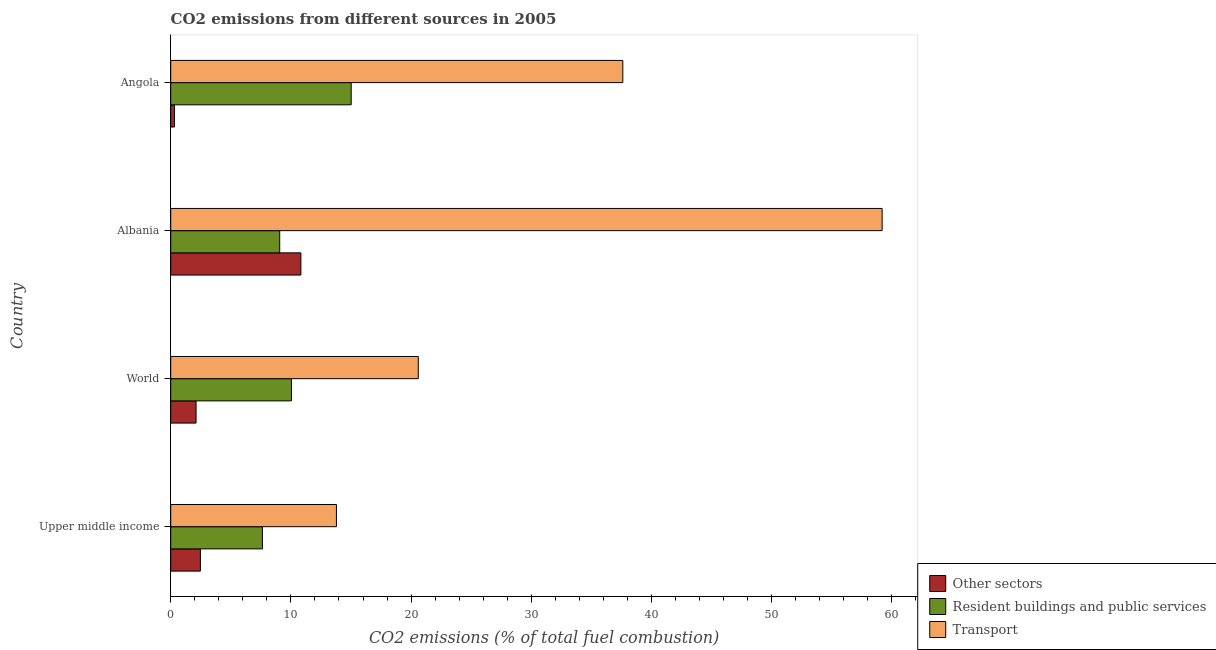Are the number of bars per tick equal to the number of legend labels?
Keep it short and to the point. Yes. How many bars are there on the 3rd tick from the bottom?
Ensure brevity in your answer.  3. What is the percentage of co2 emissions from transport in Upper middle income?
Make the answer very short. 13.79. Across all countries, what is the maximum percentage of co2 emissions from other sectors?
Your answer should be very brief. 10.83. Across all countries, what is the minimum percentage of co2 emissions from resident buildings and public services?
Provide a succinct answer. 7.63. In which country was the percentage of co2 emissions from resident buildings and public services maximum?
Ensure brevity in your answer.  Angola. In which country was the percentage of co2 emissions from transport minimum?
Provide a short and direct response. Upper middle income. What is the total percentage of co2 emissions from transport in the graph?
Your answer should be very brief. 131.2. What is the difference between the percentage of co2 emissions from other sectors in Albania and that in Angola?
Give a very brief answer. 10.52. What is the difference between the percentage of co2 emissions from resident buildings and public services in Angola and the percentage of co2 emissions from other sectors in Albania?
Provide a short and direct response. 4.18. What is the average percentage of co2 emissions from transport per country?
Your answer should be compact. 32.8. What is the difference between the percentage of co2 emissions from transport and percentage of co2 emissions from resident buildings and public services in Albania?
Your answer should be compact. 50.13. In how many countries, is the percentage of co2 emissions from other sectors greater than 60 %?
Your response must be concise. 0. What is the ratio of the percentage of co2 emissions from other sectors in Upper middle income to that in World?
Provide a short and direct response. 1.17. Is the percentage of co2 emissions from resident buildings and public services in Angola less than that in World?
Keep it short and to the point. No. What is the difference between the highest and the second highest percentage of co2 emissions from transport?
Ensure brevity in your answer.  21.58. What is the difference between the highest and the lowest percentage of co2 emissions from transport?
Offer a terse response. 45.41. In how many countries, is the percentage of co2 emissions from other sectors greater than the average percentage of co2 emissions from other sectors taken over all countries?
Your answer should be compact. 1. What does the 1st bar from the top in World represents?
Give a very brief answer. Transport. What does the 1st bar from the bottom in World represents?
Your answer should be compact. Other sectors. Is it the case that in every country, the sum of the percentage of co2 emissions from other sectors and percentage of co2 emissions from resident buildings and public services is greater than the percentage of co2 emissions from transport?
Provide a short and direct response. No. Are all the bars in the graph horizontal?
Provide a short and direct response. Yes. What is the difference between two consecutive major ticks on the X-axis?
Provide a succinct answer. 10. How many legend labels are there?
Ensure brevity in your answer.  3. What is the title of the graph?
Offer a very short reply. CO2 emissions from different sources in 2005. Does "Transport services" appear as one of the legend labels in the graph?
Give a very brief answer. No. What is the label or title of the X-axis?
Provide a succinct answer. CO2 emissions (% of total fuel combustion). What is the label or title of the Y-axis?
Your answer should be compact. Country. What is the CO2 emissions (% of total fuel combustion) of Other sectors in Upper middle income?
Offer a very short reply. 2.47. What is the CO2 emissions (% of total fuel combustion) in Resident buildings and public services in Upper middle income?
Ensure brevity in your answer.  7.63. What is the CO2 emissions (% of total fuel combustion) in Transport in Upper middle income?
Keep it short and to the point. 13.79. What is the CO2 emissions (% of total fuel combustion) of Other sectors in World?
Ensure brevity in your answer.  2.11. What is the CO2 emissions (% of total fuel combustion) in Resident buildings and public services in World?
Provide a short and direct response. 10.05. What is the CO2 emissions (% of total fuel combustion) in Transport in World?
Your answer should be compact. 20.6. What is the CO2 emissions (% of total fuel combustion) of Other sectors in Albania?
Provide a short and direct response. 10.83. What is the CO2 emissions (% of total fuel combustion) of Resident buildings and public services in Albania?
Provide a short and direct response. 9.07. What is the CO2 emissions (% of total fuel combustion) in Transport in Albania?
Offer a very short reply. 59.19. What is the CO2 emissions (% of total fuel combustion) in Other sectors in Angola?
Keep it short and to the point. 0.31. What is the CO2 emissions (% of total fuel combustion) of Resident buildings and public services in Angola?
Make the answer very short. 15.02. What is the CO2 emissions (% of total fuel combustion) in Transport in Angola?
Offer a very short reply. 37.62. Across all countries, what is the maximum CO2 emissions (% of total fuel combustion) of Other sectors?
Your answer should be compact. 10.83. Across all countries, what is the maximum CO2 emissions (% of total fuel combustion) of Resident buildings and public services?
Your answer should be compact. 15.02. Across all countries, what is the maximum CO2 emissions (% of total fuel combustion) of Transport?
Ensure brevity in your answer.  59.19. Across all countries, what is the minimum CO2 emissions (% of total fuel combustion) of Other sectors?
Your answer should be very brief. 0.31. Across all countries, what is the minimum CO2 emissions (% of total fuel combustion) in Resident buildings and public services?
Make the answer very short. 7.63. Across all countries, what is the minimum CO2 emissions (% of total fuel combustion) of Transport?
Provide a succinct answer. 13.79. What is the total CO2 emissions (% of total fuel combustion) of Other sectors in the graph?
Offer a very short reply. 15.72. What is the total CO2 emissions (% of total fuel combustion) of Resident buildings and public services in the graph?
Your answer should be very brief. 41.76. What is the total CO2 emissions (% of total fuel combustion) of Transport in the graph?
Give a very brief answer. 131.2. What is the difference between the CO2 emissions (% of total fuel combustion) of Other sectors in Upper middle income and that in World?
Ensure brevity in your answer.  0.36. What is the difference between the CO2 emissions (% of total fuel combustion) of Resident buildings and public services in Upper middle income and that in World?
Offer a terse response. -2.42. What is the difference between the CO2 emissions (% of total fuel combustion) in Transport in Upper middle income and that in World?
Your answer should be compact. -6.81. What is the difference between the CO2 emissions (% of total fuel combustion) of Other sectors in Upper middle income and that in Albania?
Make the answer very short. -8.36. What is the difference between the CO2 emissions (% of total fuel combustion) of Resident buildings and public services in Upper middle income and that in Albania?
Provide a short and direct response. -1.44. What is the difference between the CO2 emissions (% of total fuel combustion) in Transport in Upper middle income and that in Albania?
Provide a succinct answer. -45.41. What is the difference between the CO2 emissions (% of total fuel combustion) in Other sectors in Upper middle income and that in Angola?
Your response must be concise. 2.16. What is the difference between the CO2 emissions (% of total fuel combustion) in Resident buildings and public services in Upper middle income and that in Angola?
Keep it short and to the point. -7.39. What is the difference between the CO2 emissions (% of total fuel combustion) in Transport in Upper middle income and that in Angola?
Offer a very short reply. -23.83. What is the difference between the CO2 emissions (% of total fuel combustion) in Other sectors in World and that in Albania?
Keep it short and to the point. -8.72. What is the difference between the CO2 emissions (% of total fuel combustion) of Resident buildings and public services in World and that in Albania?
Your answer should be compact. 0.98. What is the difference between the CO2 emissions (% of total fuel combustion) in Transport in World and that in Albania?
Offer a terse response. -38.6. What is the difference between the CO2 emissions (% of total fuel combustion) in Other sectors in World and that in Angola?
Offer a terse response. 1.8. What is the difference between the CO2 emissions (% of total fuel combustion) of Resident buildings and public services in World and that in Angola?
Your answer should be compact. -4.97. What is the difference between the CO2 emissions (% of total fuel combustion) in Transport in World and that in Angola?
Keep it short and to the point. -17.02. What is the difference between the CO2 emissions (% of total fuel combustion) of Other sectors in Albania and that in Angola?
Your response must be concise. 10.52. What is the difference between the CO2 emissions (% of total fuel combustion) in Resident buildings and public services in Albania and that in Angola?
Offer a very short reply. -5.95. What is the difference between the CO2 emissions (% of total fuel combustion) of Transport in Albania and that in Angola?
Provide a short and direct response. 21.58. What is the difference between the CO2 emissions (% of total fuel combustion) in Other sectors in Upper middle income and the CO2 emissions (% of total fuel combustion) in Resident buildings and public services in World?
Your answer should be compact. -7.58. What is the difference between the CO2 emissions (% of total fuel combustion) in Other sectors in Upper middle income and the CO2 emissions (% of total fuel combustion) in Transport in World?
Keep it short and to the point. -18.13. What is the difference between the CO2 emissions (% of total fuel combustion) in Resident buildings and public services in Upper middle income and the CO2 emissions (% of total fuel combustion) in Transport in World?
Your answer should be very brief. -12.97. What is the difference between the CO2 emissions (% of total fuel combustion) in Other sectors in Upper middle income and the CO2 emissions (% of total fuel combustion) in Resident buildings and public services in Albania?
Your response must be concise. -6.6. What is the difference between the CO2 emissions (% of total fuel combustion) of Other sectors in Upper middle income and the CO2 emissions (% of total fuel combustion) of Transport in Albania?
Ensure brevity in your answer.  -56.72. What is the difference between the CO2 emissions (% of total fuel combustion) in Resident buildings and public services in Upper middle income and the CO2 emissions (% of total fuel combustion) in Transport in Albania?
Give a very brief answer. -51.56. What is the difference between the CO2 emissions (% of total fuel combustion) in Other sectors in Upper middle income and the CO2 emissions (% of total fuel combustion) in Resident buildings and public services in Angola?
Your response must be concise. -12.55. What is the difference between the CO2 emissions (% of total fuel combustion) in Other sectors in Upper middle income and the CO2 emissions (% of total fuel combustion) in Transport in Angola?
Give a very brief answer. -35.15. What is the difference between the CO2 emissions (% of total fuel combustion) of Resident buildings and public services in Upper middle income and the CO2 emissions (% of total fuel combustion) of Transport in Angola?
Ensure brevity in your answer.  -29.99. What is the difference between the CO2 emissions (% of total fuel combustion) in Other sectors in World and the CO2 emissions (% of total fuel combustion) in Resident buildings and public services in Albania?
Your answer should be very brief. -6.96. What is the difference between the CO2 emissions (% of total fuel combustion) in Other sectors in World and the CO2 emissions (% of total fuel combustion) in Transport in Albania?
Provide a succinct answer. -57.09. What is the difference between the CO2 emissions (% of total fuel combustion) of Resident buildings and public services in World and the CO2 emissions (% of total fuel combustion) of Transport in Albania?
Offer a very short reply. -49.15. What is the difference between the CO2 emissions (% of total fuel combustion) of Other sectors in World and the CO2 emissions (% of total fuel combustion) of Resident buildings and public services in Angola?
Provide a succinct answer. -12.91. What is the difference between the CO2 emissions (% of total fuel combustion) in Other sectors in World and the CO2 emissions (% of total fuel combustion) in Transport in Angola?
Your answer should be very brief. -35.51. What is the difference between the CO2 emissions (% of total fuel combustion) in Resident buildings and public services in World and the CO2 emissions (% of total fuel combustion) in Transport in Angola?
Offer a terse response. -27.57. What is the difference between the CO2 emissions (% of total fuel combustion) of Other sectors in Albania and the CO2 emissions (% of total fuel combustion) of Resident buildings and public services in Angola?
Offer a terse response. -4.18. What is the difference between the CO2 emissions (% of total fuel combustion) of Other sectors in Albania and the CO2 emissions (% of total fuel combustion) of Transport in Angola?
Offer a very short reply. -26.78. What is the difference between the CO2 emissions (% of total fuel combustion) in Resident buildings and public services in Albania and the CO2 emissions (% of total fuel combustion) in Transport in Angola?
Provide a short and direct response. -28.55. What is the average CO2 emissions (% of total fuel combustion) of Other sectors per country?
Provide a succinct answer. 3.93. What is the average CO2 emissions (% of total fuel combustion) of Resident buildings and public services per country?
Provide a succinct answer. 10.44. What is the average CO2 emissions (% of total fuel combustion) of Transport per country?
Give a very brief answer. 32.8. What is the difference between the CO2 emissions (% of total fuel combustion) in Other sectors and CO2 emissions (% of total fuel combustion) in Resident buildings and public services in Upper middle income?
Ensure brevity in your answer.  -5.16. What is the difference between the CO2 emissions (% of total fuel combustion) of Other sectors and CO2 emissions (% of total fuel combustion) of Transport in Upper middle income?
Keep it short and to the point. -11.32. What is the difference between the CO2 emissions (% of total fuel combustion) in Resident buildings and public services and CO2 emissions (% of total fuel combustion) in Transport in Upper middle income?
Give a very brief answer. -6.16. What is the difference between the CO2 emissions (% of total fuel combustion) of Other sectors and CO2 emissions (% of total fuel combustion) of Resident buildings and public services in World?
Your answer should be compact. -7.94. What is the difference between the CO2 emissions (% of total fuel combustion) in Other sectors and CO2 emissions (% of total fuel combustion) in Transport in World?
Give a very brief answer. -18.49. What is the difference between the CO2 emissions (% of total fuel combustion) in Resident buildings and public services and CO2 emissions (% of total fuel combustion) in Transport in World?
Offer a terse response. -10.55. What is the difference between the CO2 emissions (% of total fuel combustion) in Other sectors and CO2 emissions (% of total fuel combustion) in Resident buildings and public services in Albania?
Your answer should be very brief. 1.76. What is the difference between the CO2 emissions (% of total fuel combustion) of Other sectors and CO2 emissions (% of total fuel combustion) of Transport in Albania?
Give a very brief answer. -48.36. What is the difference between the CO2 emissions (% of total fuel combustion) in Resident buildings and public services and CO2 emissions (% of total fuel combustion) in Transport in Albania?
Make the answer very short. -50.13. What is the difference between the CO2 emissions (% of total fuel combustion) in Other sectors and CO2 emissions (% of total fuel combustion) in Resident buildings and public services in Angola?
Provide a succinct answer. -14.71. What is the difference between the CO2 emissions (% of total fuel combustion) in Other sectors and CO2 emissions (% of total fuel combustion) in Transport in Angola?
Offer a terse response. -37.31. What is the difference between the CO2 emissions (% of total fuel combustion) in Resident buildings and public services and CO2 emissions (% of total fuel combustion) in Transport in Angola?
Your answer should be compact. -22.6. What is the ratio of the CO2 emissions (% of total fuel combustion) in Other sectors in Upper middle income to that in World?
Provide a short and direct response. 1.17. What is the ratio of the CO2 emissions (% of total fuel combustion) in Resident buildings and public services in Upper middle income to that in World?
Your response must be concise. 0.76. What is the ratio of the CO2 emissions (% of total fuel combustion) in Transport in Upper middle income to that in World?
Give a very brief answer. 0.67. What is the ratio of the CO2 emissions (% of total fuel combustion) of Other sectors in Upper middle income to that in Albania?
Your answer should be very brief. 0.23. What is the ratio of the CO2 emissions (% of total fuel combustion) of Resident buildings and public services in Upper middle income to that in Albania?
Keep it short and to the point. 0.84. What is the ratio of the CO2 emissions (% of total fuel combustion) in Transport in Upper middle income to that in Albania?
Offer a very short reply. 0.23. What is the ratio of the CO2 emissions (% of total fuel combustion) of Other sectors in Upper middle income to that in Angola?
Make the answer very short. 7.98. What is the ratio of the CO2 emissions (% of total fuel combustion) of Resident buildings and public services in Upper middle income to that in Angola?
Your answer should be very brief. 0.51. What is the ratio of the CO2 emissions (% of total fuel combustion) in Transport in Upper middle income to that in Angola?
Provide a succinct answer. 0.37. What is the ratio of the CO2 emissions (% of total fuel combustion) of Other sectors in World to that in Albania?
Keep it short and to the point. 0.19. What is the ratio of the CO2 emissions (% of total fuel combustion) in Resident buildings and public services in World to that in Albania?
Make the answer very short. 1.11. What is the ratio of the CO2 emissions (% of total fuel combustion) in Transport in World to that in Albania?
Keep it short and to the point. 0.35. What is the ratio of the CO2 emissions (% of total fuel combustion) in Other sectors in World to that in Angola?
Offer a terse response. 6.81. What is the ratio of the CO2 emissions (% of total fuel combustion) in Resident buildings and public services in World to that in Angola?
Keep it short and to the point. 0.67. What is the ratio of the CO2 emissions (% of total fuel combustion) in Transport in World to that in Angola?
Keep it short and to the point. 0.55. What is the ratio of the CO2 emissions (% of total fuel combustion) of Other sectors in Albania to that in Angola?
Keep it short and to the point. 34.98. What is the ratio of the CO2 emissions (% of total fuel combustion) in Resident buildings and public services in Albania to that in Angola?
Your response must be concise. 0.6. What is the ratio of the CO2 emissions (% of total fuel combustion) of Transport in Albania to that in Angola?
Give a very brief answer. 1.57. What is the difference between the highest and the second highest CO2 emissions (% of total fuel combustion) of Other sectors?
Offer a terse response. 8.36. What is the difference between the highest and the second highest CO2 emissions (% of total fuel combustion) in Resident buildings and public services?
Provide a short and direct response. 4.97. What is the difference between the highest and the second highest CO2 emissions (% of total fuel combustion) of Transport?
Ensure brevity in your answer.  21.58. What is the difference between the highest and the lowest CO2 emissions (% of total fuel combustion) of Other sectors?
Provide a succinct answer. 10.52. What is the difference between the highest and the lowest CO2 emissions (% of total fuel combustion) in Resident buildings and public services?
Make the answer very short. 7.39. What is the difference between the highest and the lowest CO2 emissions (% of total fuel combustion) in Transport?
Your answer should be compact. 45.41. 